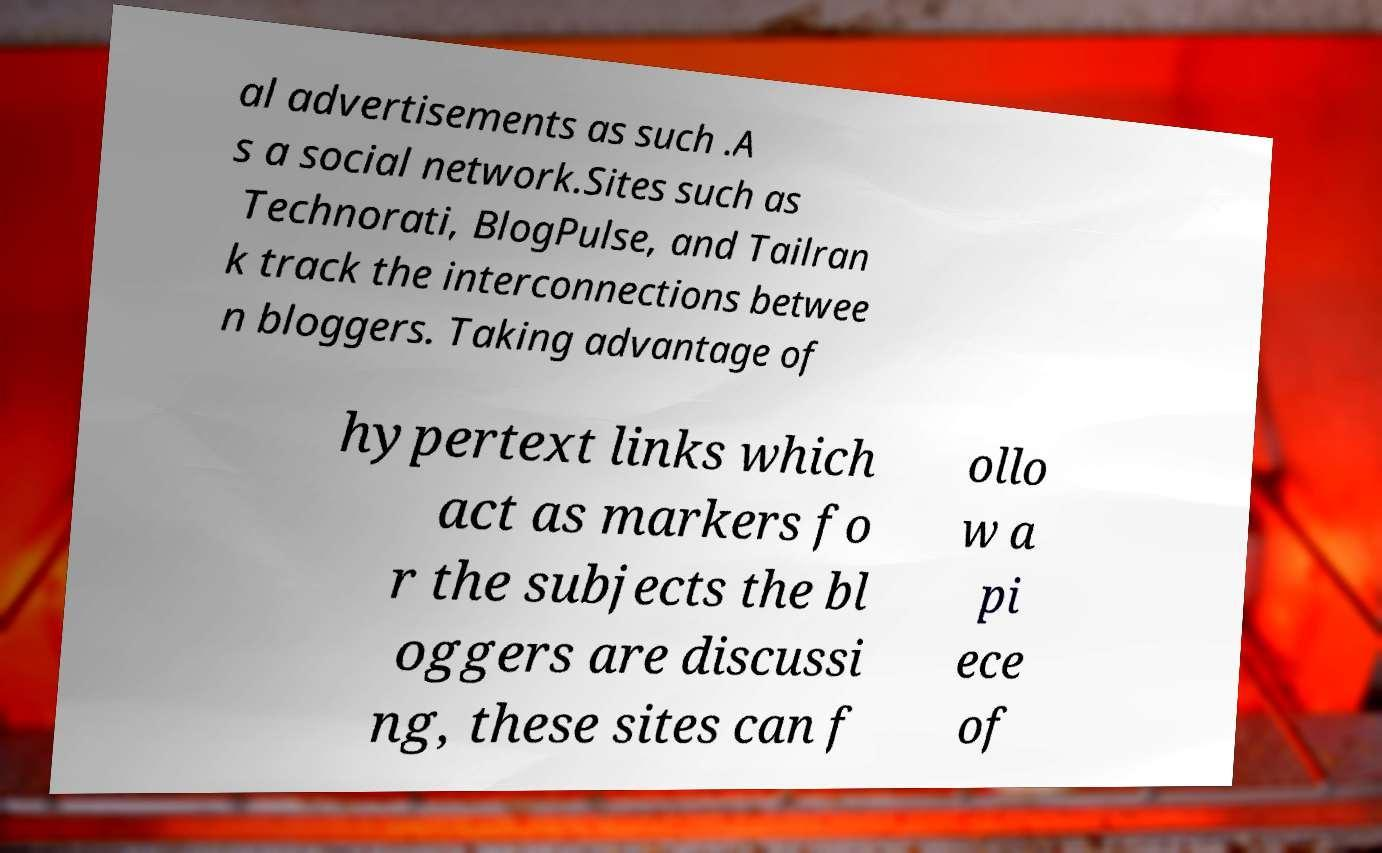Can you read and provide the text displayed in the image?This photo seems to have some interesting text. Can you extract and type it out for me? al advertisements as such .A s a social network.Sites such as Technorati, BlogPulse, and Tailran k track the interconnections betwee n bloggers. Taking advantage of hypertext links which act as markers fo r the subjects the bl oggers are discussi ng, these sites can f ollo w a pi ece of 